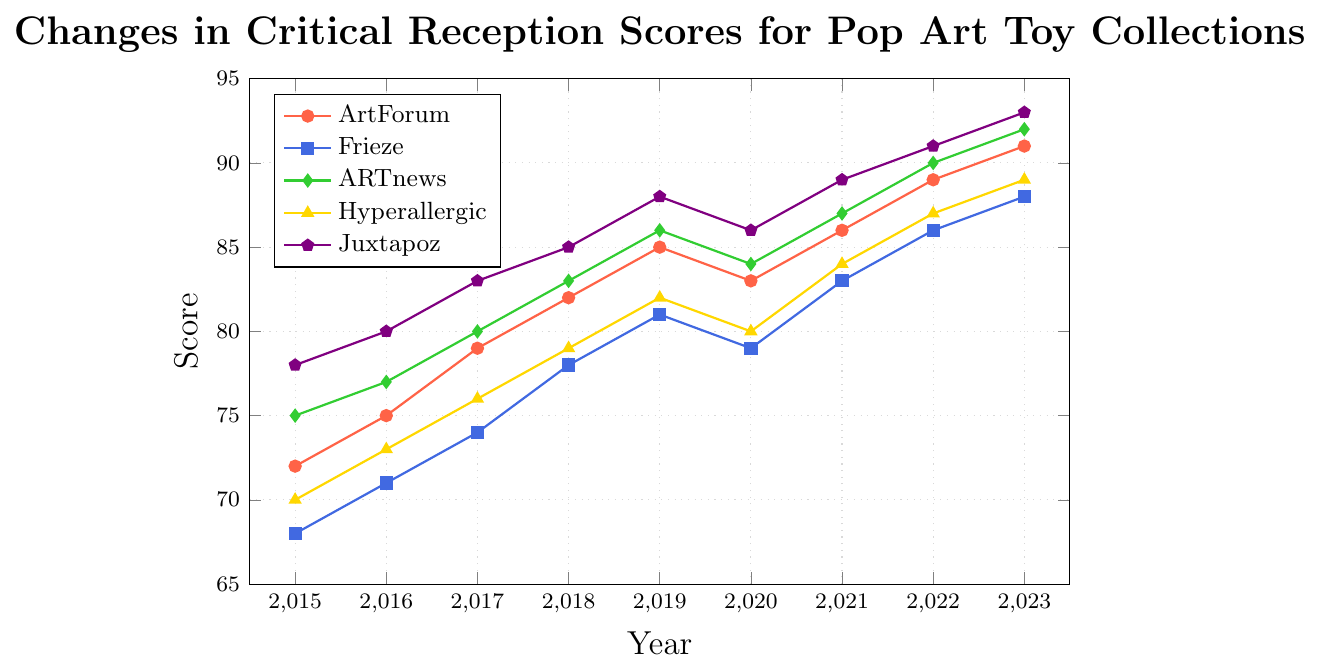What is the overall trend of ArtForum's scores from 2015 to 2023? The scores from ArtForum consistently increase every year, starting at 72 in 2015 and reaching 91 in 2023, except for a slight dip in 2020 to 83 from 85 in 2019.
Answer: Increasing trend with slight dip in 2020 In which year did Juxtapoz scores reach the highest value based on the graph? The highest score for Juxtapoz is shown in 2023, where the score is 93.
Answer: 2023 Between Hyperallergic and Frieze, which publication had a higher score in 2020 and by how much? In 2020, the score for Hyperallergic was 80 while the score for Frieze was 79. By subtracting the Frieze score from the Hyperallergic score, we get 80 - 79 = 1.
Answer: Hyperallergic by 1 What is the average score of ARTnews from 2015 to 2023? To find the average score, sum the yearly scores for ARTnews and divide by the number of years: (75 + 77 + 80 + 83 + 86 + 84 + 87 + 90 + 92) / 9 = 754 / 9 ≈ 83.78.
Answer: 83.78 Which publication had the least variation in scores from 2015 to 2023? To find the least variation, look at the scores of each publication over the years. ARTnews scores increase steadily from 75 to 92, suggesting more consistency compared to other publications.
Answer: ARTnews How many years did Frieze score less than ARTnews from 2015 to 2023? For each year between 2015 and 2023, compare the scores of Frieze and ARTnews: Frieze scores are lower than ARTnews in all years: (2015-2023).
Answer: 9 years What was the difference in ArtForum's score between the years 2018 and 2020? ArtForum's score in 2018 was 82 and in 2020 it was 83. The difference is 83 - 82 = 1.
Answer: 1 In 2022, which publication had the highest critical reception score? Looking at the scores for each publication in 2022, Juxtapoz has the highest score of 91.
Answer: Juxtapoz Which year saw the highest increase in ARTnews scores compared to the previous year? Examine the yearly difference for ARTnews: The highest increase is from 2019 to 2020, where the score increased from 86 to 84, an increase of 4 points.
Answer: 2017 (Increase by 3) Which publication had the least increase in scores between 2021 and 2022? Between 2021 and 2022, the scores for ArtForum increased from 86 to 89 (an increase of 3), Frieze from 83 to 86 (3), ARTnews from 90 to 92 (2), Hyperallergic from 84 to 87 (3), and Juxtapoz from 89 to 91 (2). Therefore, ARTnews and Juxtapoz had the least increase.
Answer: ARTnews and Juxtapoz 